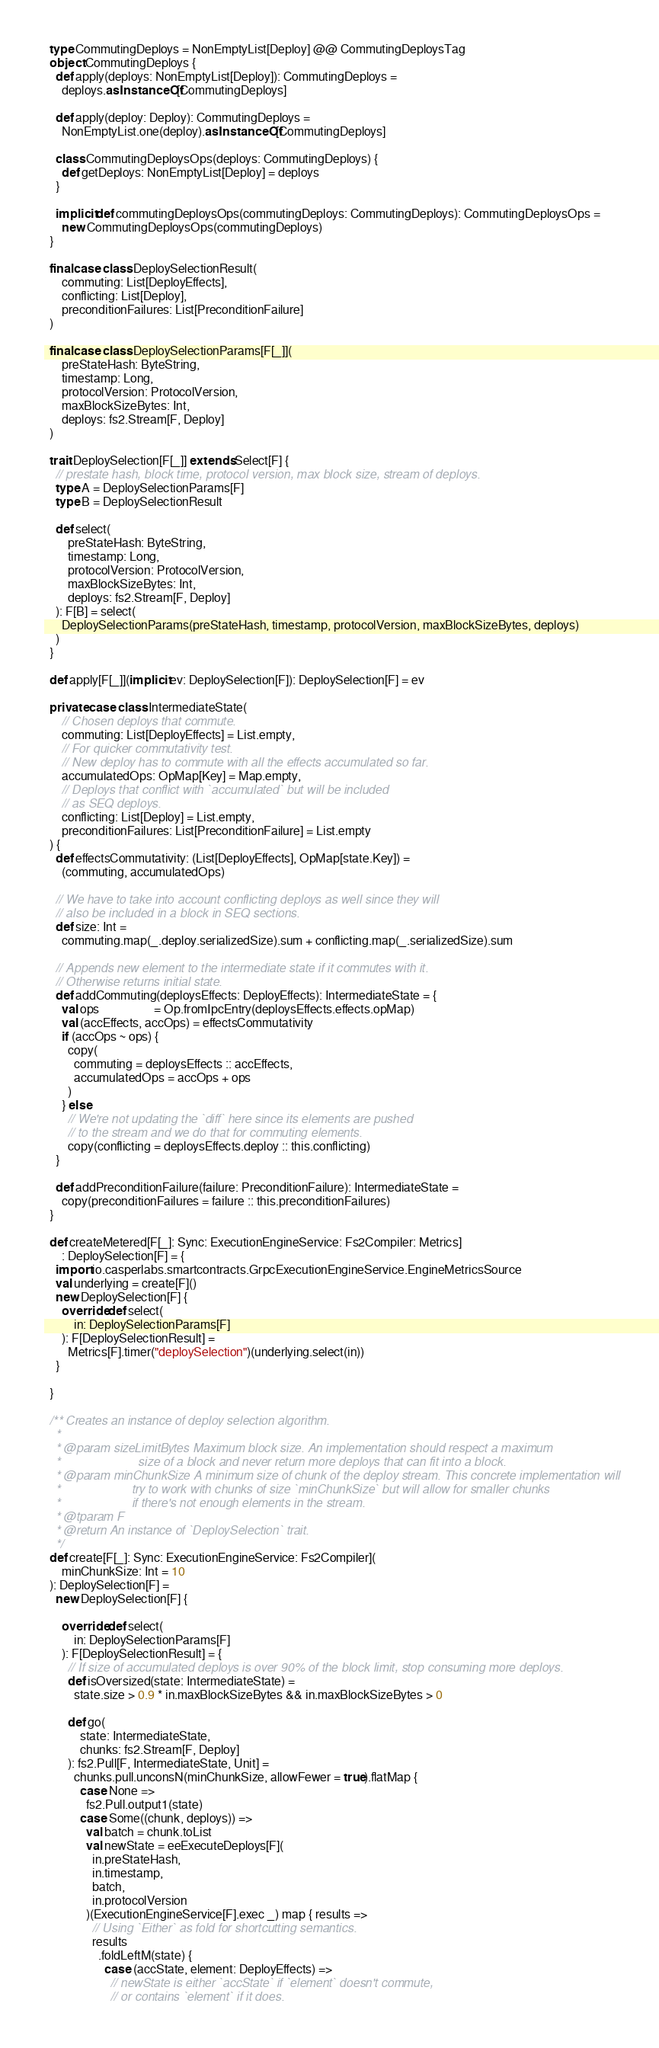<code> <loc_0><loc_0><loc_500><loc_500><_Scala_>  type CommutingDeploys = NonEmptyList[Deploy] @@ CommutingDeploysTag
  object CommutingDeploys {
    def apply(deploys: NonEmptyList[Deploy]): CommutingDeploys =
      deploys.asInstanceOf[CommutingDeploys]

    def apply(deploy: Deploy): CommutingDeploys =
      NonEmptyList.one(deploy).asInstanceOf[CommutingDeploys]

    class CommutingDeploysOps(deploys: CommutingDeploys) {
      def getDeploys: NonEmptyList[Deploy] = deploys
    }

    implicit def commutingDeploysOps(commutingDeploys: CommutingDeploys): CommutingDeploysOps =
      new CommutingDeploysOps(commutingDeploys)
  }

  final case class DeploySelectionResult(
      commuting: List[DeployEffects],
      conflicting: List[Deploy],
      preconditionFailures: List[PreconditionFailure]
  )

  final case class DeploySelectionParams[F[_]](
      preStateHash: ByteString,
      timestamp: Long,
      protocolVersion: ProtocolVersion,
      maxBlockSizeBytes: Int,
      deploys: fs2.Stream[F, Deploy]
  )

  trait DeploySelection[F[_]] extends Select[F] {
    // prestate hash, block time, protocol version, max block size, stream of deploys.
    type A = DeploySelectionParams[F]
    type B = DeploySelectionResult

    def select(
        preStateHash: ByteString,
        timestamp: Long,
        protocolVersion: ProtocolVersion,
        maxBlockSizeBytes: Int,
        deploys: fs2.Stream[F, Deploy]
    ): F[B] = select(
      DeploySelectionParams(preStateHash, timestamp, protocolVersion, maxBlockSizeBytes, deploys)
    )
  }

  def apply[F[_]](implicit ev: DeploySelection[F]): DeploySelection[F] = ev

  private case class IntermediateState(
      // Chosen deploys that commute.
      commuting: List[DeployEffects] = List.empty,
      // For quicker commutativity test.
      // New deploy has to commute with all the effects accumulated so far.
      accumulatedOps: OpMap[Key] = Map.empty,
      // Deploys that conflict with `accumulated` but will be included
      // as SEQ deploys.
      conflicting: List[Deploy] = List.empty,
      preconditionFailures: List[PreconditionFailure] = List.empty
  ) {
    def effectsCommutativity: (List[DeployEffects], OpMap[state.Key]) =
      (commuting, accumulatedOps)

    // We have to take into account conflicting deploys as well since they will
    // also be included in a block in SEQ sections.
    def size: Int =
      commuting.map(_.deploy.serializedSize).sum + conflicting.map(_.serializedSize).sum

    // Appends new element to the intermediate state if it commutes with it.
    // Otherwise returns initial state.
    def addCommuting(deploysEffects: DeployEffects): IntermediateState = {
      val ops                  = Op.fromIpcEntry(deploysEffects.effects.opMap)
      val (accEffects, accOps) = effectsCommutativity
      if (accOps ~ ops) {
        copy(
          commuting = deploysEffects :: accEffects,
          accumulatedOps = accOps + ops
        )
      } else
        // We're not updating the `diff` here since its elements are pushed
        // to the stream and we do that for commuting elements.
        copy(conflicting = deploysEffects.deploy :: this.conflicting)
    }

    def addPreconditionFailure(failure: PreconditionFailure): IntermediateState =
      copy(preconditionFailures = failure :: this.preconditionFailures)
  }

  def createMetered[F[_]: Sync: ExecutionEngineService: Fs2Compiler: Metrics]
      : DeploySelection[F] = {
    import io.casperlabs.smartcontracts.GrpcExecutionEngineService.EngineMetricsSource
    val underlying = create[F]()
    new DeploySelection[F] {
      override def select(
          in: DeploySelectionParams[F]
      ): F[DeploySelectionResult] =
        Metrics[F].timer("deploySelection")(underlying.select(in))
    }

  }

  /** Creates an instance of deploy selection algorithm.
    *
    * @param sizeLimitBytes Maximum block size. An implementation should respect a maximum
    *                       size of a block and never return more deploys that can fit into a block.
    * @param minChunkSize A minimum size of chunk of the deploy stream. This concrete implementation will
    *                     try to work with chunks of size `minChunkSize` but will allow for smaller chunks
    *                     if there's not enough elements in the stream.
    * @tparam F
    * @return An instance of `DeploySelection` trait.
    */
  def create[F[_]: Sync: ExecutionEngineService: Fs2Compiler](
      minChunkSize: Int = 10
  ): DeploySelection[F] =
    new DeploySelection[F] {

      override def select(
          in: DeploySelectionParams[F]
      ): F[DeploySelectionResult] = {
        // If size of accumulated deploys is over 90% of the block limit, stop consuming more deploys.
        def isOversized(state: IntermediateState) =
          state.size > 0.9 * in.maxBlockSizeBytes && in.maxBlockSizeBytes > 0

        def go(
            state: IntermediateState,
            chunks: fs2.Stream[F, Deploy]
        ): fs2.Pull[F, IntermediateState, Unit] =
          chunks.pull.unconsN(minChunkSize, allowFewer = true).flatMap {
            case None =>
              fs2.Pull.output1(state)
            case Some((chunk, deploys)) =>
              val batch = chunk.toList
              val newState = eeExecuteDeploys[F](
                in.preStateHash,
                in.timestamp,
                batch,
                in.protocolVersion
              )(ExecutionEngineService[F].exec _) map { results =>
                // Using `Either` as fold for shortcutting semantics.
                results
                  .foldLeftM(state) {
                    case (accState, element: DeployEffects) =>
                      // newState is either `accState` if `element` doesn't commute,
                      // or contains `element` if it does.</code> 